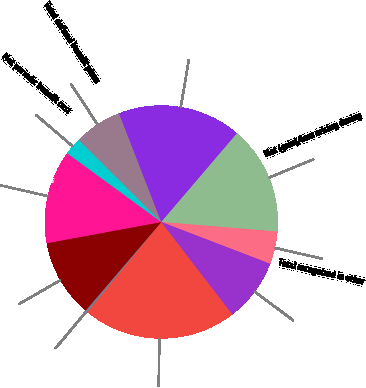Convert chart. <chart><loc_0><loc_0><loc_500><loc_500><pie_chart><fcel>Year ended December 31 (in<fcel>Benefits earned during the<fcel>Interest cost on benefit<fcel>Expected return on plan assets<fcel>Net periodic benefit cost<fcel>Total defined benefit plans<fcel>Total pension and OPEB cost<fcel>Net (gain)/loss arising during<fcel>Total recognized in other<fcel>Total recognized in net<nl><fcel>21.38%<fcel>0.31%<fcel>10.84%<fcel>12.95%<fcel>2.42%<fcel>6.63%<fcel>17.16%<fcel>15.06%<fcel>4.52%<fcel>8.74%<nl></chart> 